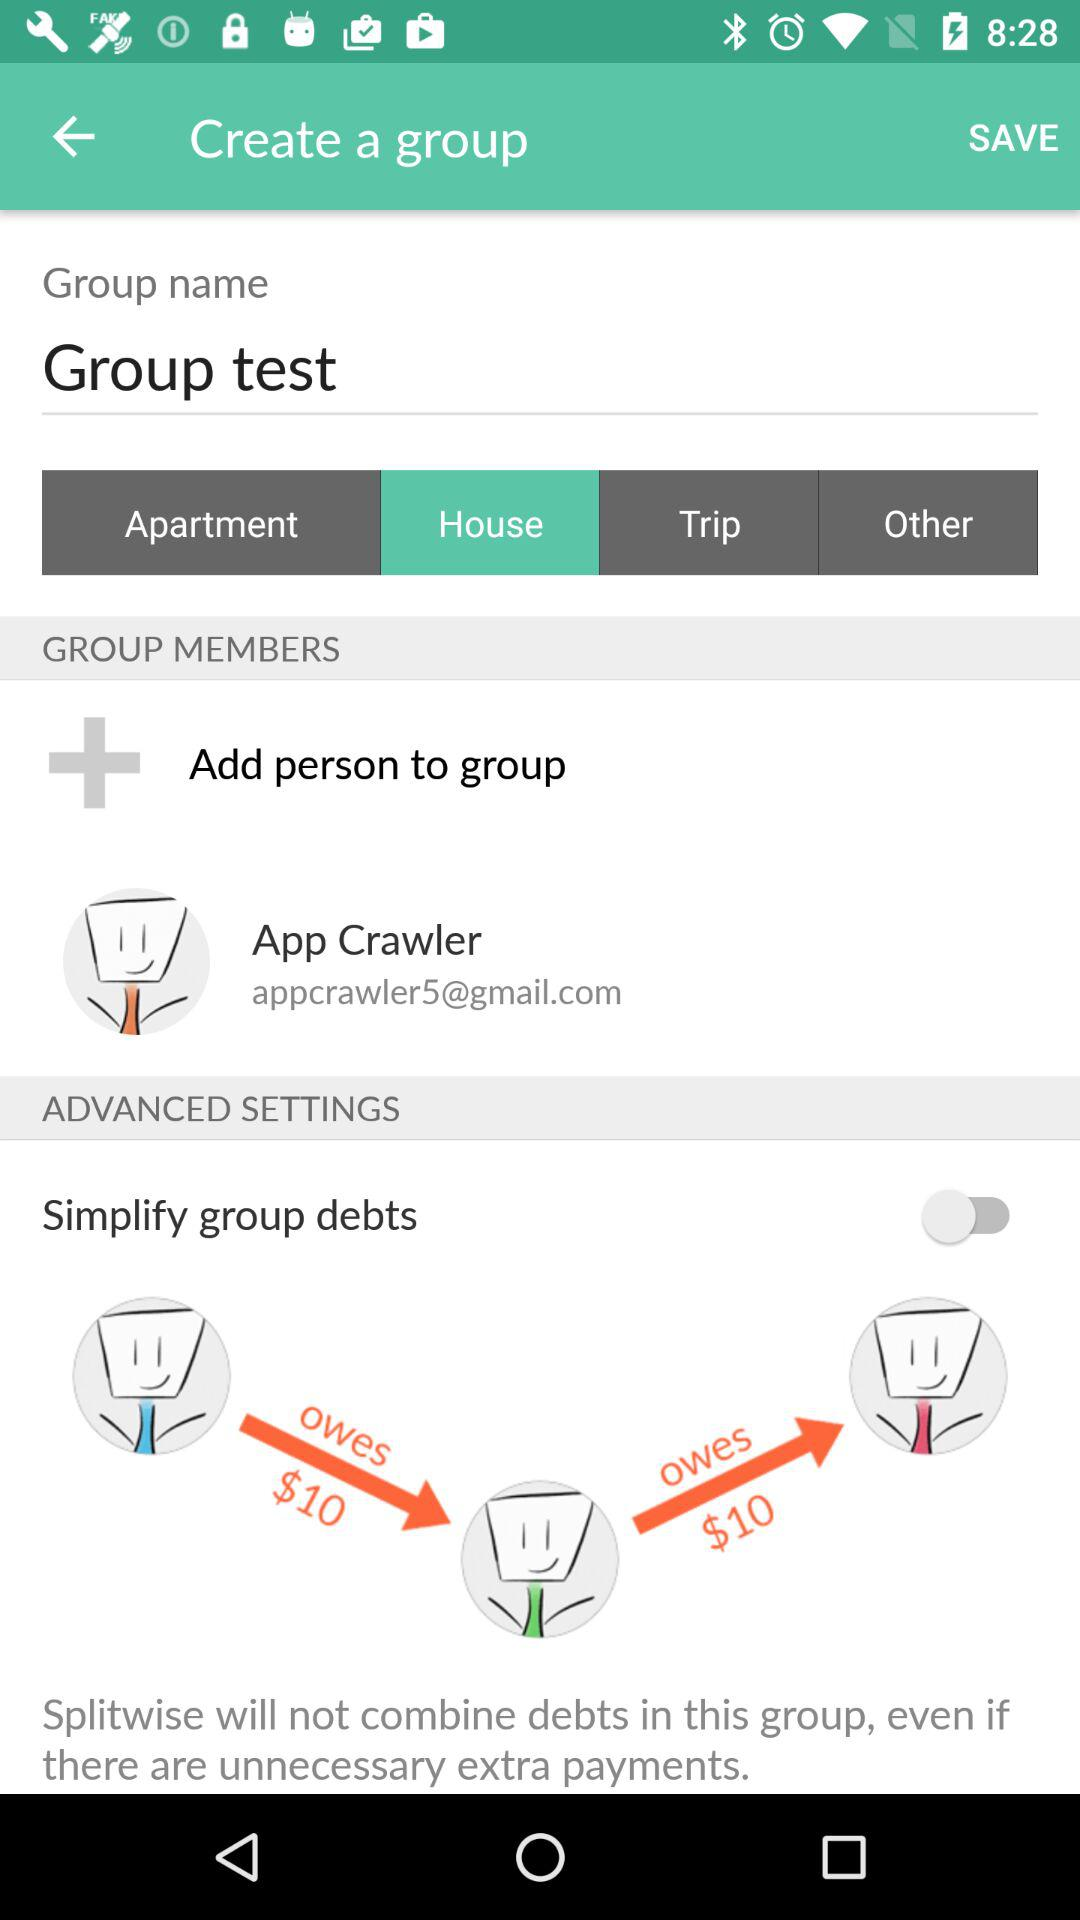What is the email address of the group member? The email address is appcrawler5@gmail.com. 